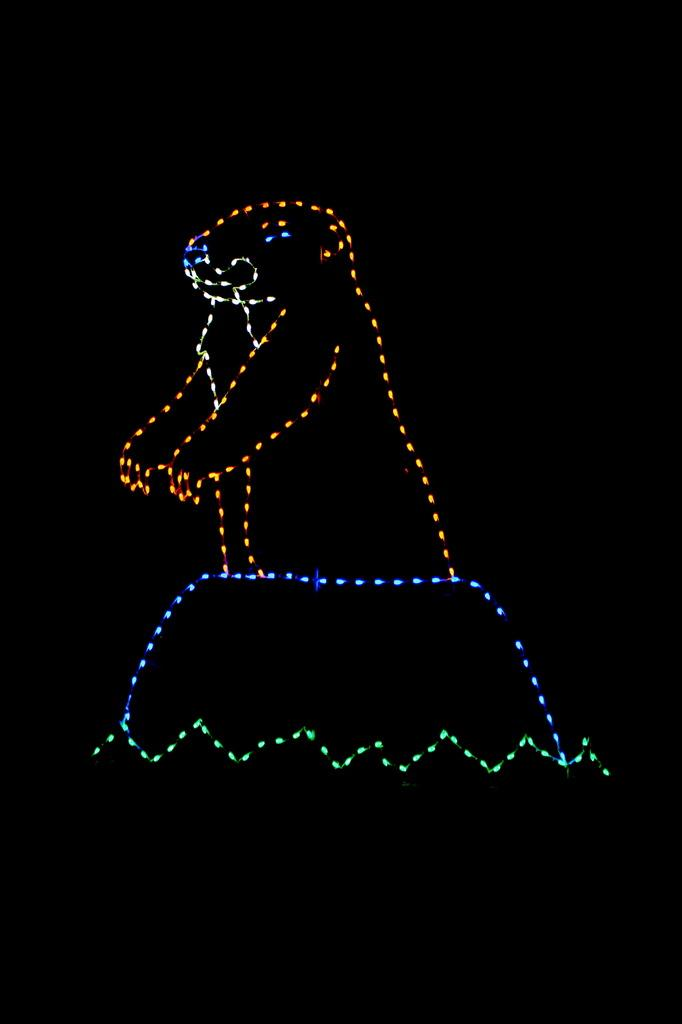What is present in the image that emits light? There are lights in the image. What colors can be seen in the lights? The colors of the lights are green, blue, orange, and white. Can you describe the overall lighting in the image? The image appears to be slightly dark. Is there a volcano erupting in the image? No, there is no volcano present in the image. Can you see an owl perched on one of the lights in the image? No, there is no owl present in the image. 